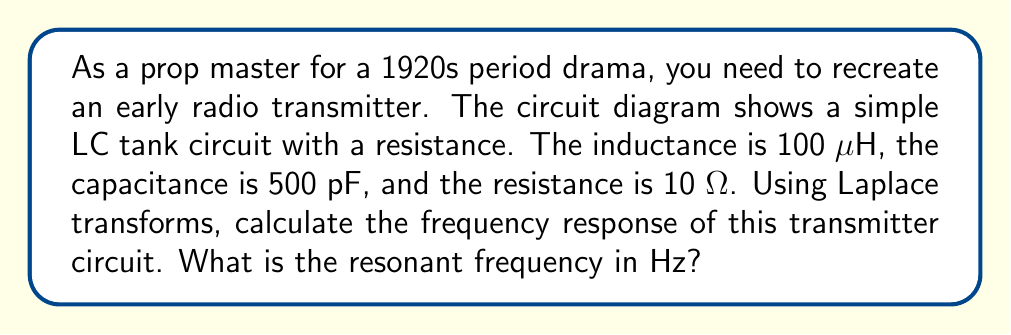What is the answer to this math problem? Let's approach this step-by-step using Laplace transforms:

1) First, we need to write the transfer function of the circuit. For an RLC series circuit, the transfer function is:

   $$H(s) = \frac{1/LC}{s^2 + (R/L)s + 1/LC}$$

2) We're given:
   L = 100 μH = $1 \times 10^{-4}$ H
   C = 500 pF = $5 \times 10^{-10}$ F
   R = 10 Ω

3) Let's substitute these values into our transfer function:

   $$H(s) = \frac{1/(1 \times 10^{-4} \cdot 5 \times 10^{-10})}{s^2 + (10/(1 \times 10^{-4}))s + 1/(1 \times 10^{-4} \cdot 5 \times 10^{-10})}$$

4) Simplifying:

   $$H(s) = \frac{2 \times 10^{13}}{s^2 + 1 \times 10^5s + 2 \times 10^{13}}$$

5) The resonant frequency of an RLC circuit is given by:

   $$\omega_0 = \sqrt{\frac{1}{LC}}$$

6) Substituting our values:

   $$\omega_0 = \sqrt{\frac{1}{1 \times 10^{-4} \cdot 5 \times 10^{-10}}} = \sqrt{2 \times 10^{13}} \approx 1.41 \times 10^7 \text{ rad/s}$$

7) To convert from angular frequency (rad/s) to frequency (Hz), we divide by 2π:

   $$f_0 = \frac{\omega_0}{2\pi} = \frac{1.41 \times 10^7}{2\pi} \approx 2.25 \times 10^6 \text{ Hz}$$
Answer: The resonant frequency of the early radio transmitter is approximately 2.25 MHz. 